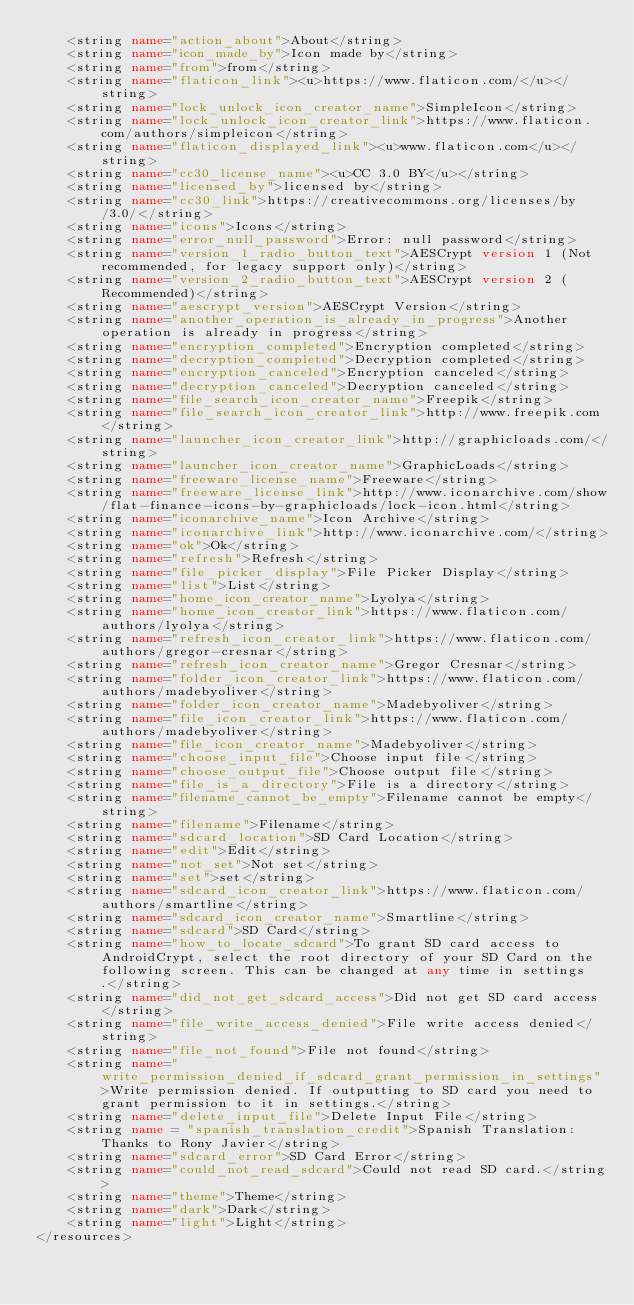<code> <loc_0><loc_0><loc_500><loc_500><_XML_>    <string name="action_about">About</string>
    <string name="icon_made_by">Icon made by</string>
    <string name="from">from</string>
    <string name="flaticon_link"><u>https://www.flaticon.com/</u></string>
    <string name="lock_unlock_icon_creator_name">SimpleIcon</string>
    <string name="lock_unlock_icon_creator_link">https://www.flaticon.com/authors/simpleicon</string>
    <string name="flaticon_displayed_link"><u>www.flaticon.com</u></string>
    <string name="cc30_license_name"><u>CC 3.0 BY</u></string>
    <string name="licensed_by">licensed by</string>
    <string name="cc30_link">https://creativecommons.org/licenses/by/3.0/</string>
    <string name="icons">Icons</string>
    <string name="error_null_password">Error: null password</string>
    <string name="version_1_radio_button_text">AESCrypt version 1 (Not recommended, for legacy support only)</string>
    <string name="version_2_radio_button_text">AESCrypt version 2 (Recommended)</string>
    <string name="aescrypt_version">AESCrypt Version</string>
    <string name="another_operation_is_already_in_progress">Another operation is already in progress</string>
    <string name="encryption_completed">Encryption completed</string>
    <string name="decryption_completed">Decryption completed</string>
    <string name="encryption_canceled">Encryption canceled</string>
    <string name="decryption_canceled">Decryption canceled</string>
    <string name="file_search_icon_creator_name">Freepik</string>
    <string name="file_search_icon_creator_link">http://www.freepik.com</string>
    <string name="launcher_icon_creator_link">http://graphicloads.com/</string>
    <string name="launcher_icon_creator_name">GraphicLoads</string>
    <string name="freeware_license_name">Freeware</string>
    <string name="freeware_license_link">http://www.iconarchive.com/show/flat-finance-icons-by-graphicloads/lock-icon.html</string>
    <string name="iconarchive_name">Icon Archive</string>
    <string name="iconarchive_link">http://www.iconarchive.com/</string>
    <string name="ok">Ok</string>
    <string name="refresh">Refresh</string>
    <string name="file_picker_display">File Picker Display</string>
    <string name="list">List</string>
    <string name="home_icon_creator_name">Lyolya</string>
    <string name="home_icon_creator_link">https://www.flaticon.com/authors/lyolya</string>
    <string name="refresh_icon_creator_link">https://www.flaticon.com/authors/gregor-cresnar</string>
    <string name="refresh_icon_creator_name">Gregor Cresnar</string>
    <string name="folder_icon_creator_link">https://www.flaticon.com/authors/madebyoliver</string>
    <string name="folder_icon_creator_name">Madebyoliver</string>
    <string name="file_icon_creator_link">https://www.flaticon.com/authors/madebyoliver</string>
    <string name="file_icon_creator_name">Madebyoliver</string>
    <string name="choose_input_file">Choose input file</string>
    <string name="choose_output_file">Choose output file</string>
    <string name="file_is_a_directory">File is a directory</string>
    <string name="filename_cannot_be_empty">Filename cannot be empty</string>
    <string name="filename">Filename</string>
    <string name="sdcard_location">SD Card Location</string>
    <string name="edit">Edit</string>
    <string name="not_set">Not set</string>
    <string name="set">set</string>
    <string name="sdcard_icon_creator_link">https://www.flaticon.com/authors/smartline</string>
    <string name="sdcard_icon_creator_name">Smartline</string>
    <string name="sdcard">SD Card</string>
    <string name="how_to_locate_sdcard">To grant SD card access to AndroidCrypt, select the root directory of your SD Card on the following screen. This can be changed at any time in settings.</string>
    <string name="did_not_get_sdcard_access">Did not get SD card access</string>
    <string name="file_write_access_denied">File write access denied</string>
    <string name="file_not_found">File not found</string>
    <string name="write_permission_denied_if_sdcard_grant_permission_in_settings">Write permission denied. If outputting to SD card you need to grant permission to it in settings.</string>
    <string name="delete_input_file">Delete Input File</string>
    <string name = "spanish_translation_credit">Spanish Translation: Thanks to Rony Javier</string>
    <string name="sdcard_error">SD Card Error</string>
    <string name="could_not_read_sdcard">Could not read SD card.</string>
    <string name="theme">Theme</string>
    <string name="dark">Dark</string>
    <string name="light">Light</string>
</resources>
</code> 